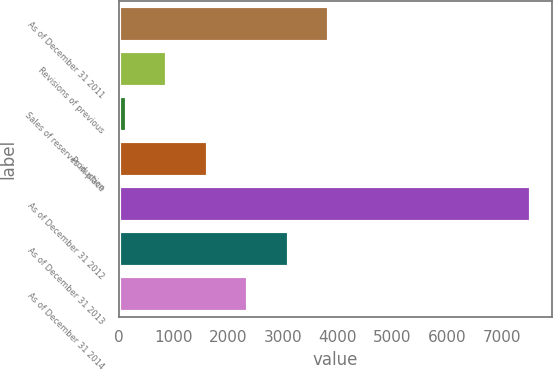Convert chart. <chart><loc_0><loc_0><loc_500><loc_500><bar_chart><fcel>As of December 31 2011<fcel>Revisions of previous<fcel>Sales of reserves in place<fcel>Production<fcel>As of December 31 2012<fcel>As of December 31 2013<fcel>As of December 31 2014<nl><fcel>3841<fcel>882.6<fcel>143<fcel>1622.2<fcel>7539<fcel>3101.4<fcel>2361.8<nl></chart> 